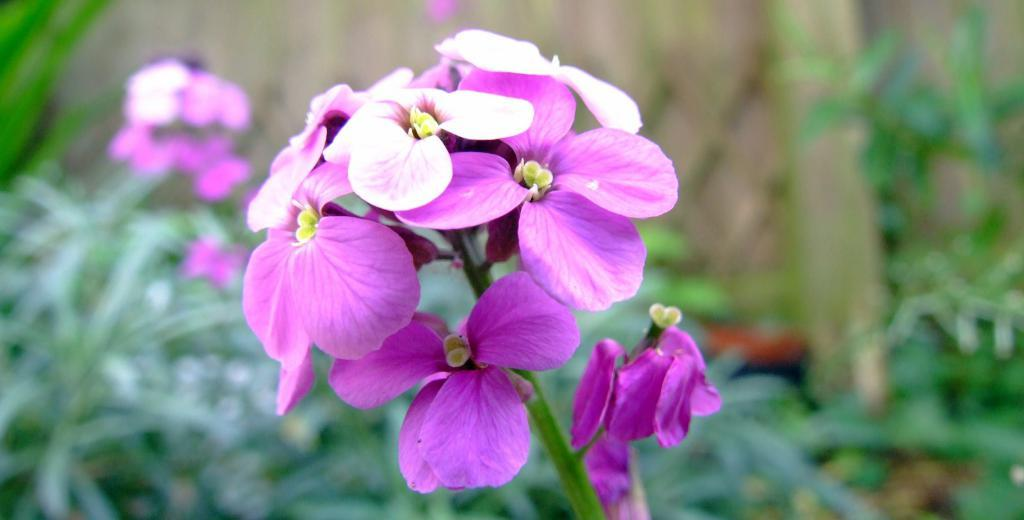What type of plants can be seen in the image? There are flower plants in the image. What colors are the flowers? The flowers are in pink and white colors. Can you describe the background of the image? The background of the image is blurred. What reason does the brass have for being in the image? There is no brass present in the image, so it cannot be determined why it would be there or what reason it might have for being in the image. 